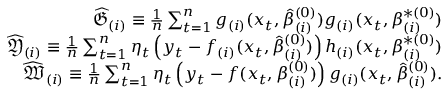<formula> <loc_0><loc_0><loc_500><loc_500>\begin{array} { r l r } & { \widehat { \mathfrak { G } } _ { ( i ) } \equiv \frac { 1 } { n } \sum _ { t = 1 } ^ { n } g _ { ( i ) } ( x _ { t } , \hat { \beta } _ { ( i ) } ^ { ( 0 ) } ) g _ { ( i ) } ( x _ { t } , \beta _ { ( i ) } ^ { \ast ( 0 ) } ) } \\ & { \widehat { \mathfrak { Y } } _ { ( i ) } \equiv \frac { 1 } { n } \sum _ { t = 1 } ^ { n } \eta _ { t } \left ( y _ { t } - f _ { ( i ) } ( x _ { t } , \hat { \beta } _ { ( i ) } ^ { ( 0 ) } ) \right ) h _ { ( i ) } ( x _ { t } , \beta _ { ( i ) } ^ { \ast ( 0 ) } ) } \\ & { \widehat { \mathfrak { W } } _ { ( i ) } \equiv \frac { 1 } { n } \sum _ { t = 1 } ^ { n } \eta _ { t } \left ( y _ { t } - f ( x _ { t } , \beta _ { ( i ) } ^ { ( 0 ) } ) \right ) g _ { ( i ) } ( x _ { t } , \hat { \beta } _ { ( i ) } ^ { ( 0 ) } ) . } \end{array}</formula> 